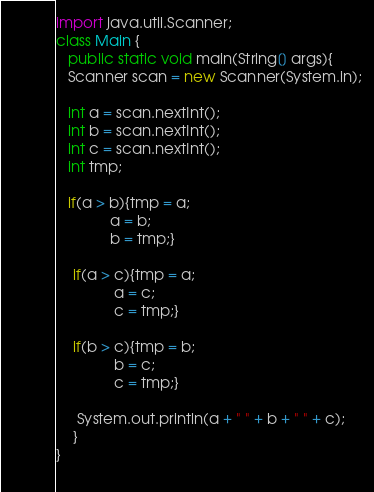<code> <loc_0><loc_0><loc_500><loc_500><_Java_>import java.util.Scanner;
class Main {
   public static void main(String[] args){
   Scanner scan = new Scanner(System.in);
 
   int a = scan.nextInt();
   int b = scan.nextInt();
   int c = scan.nextInt();
   int tmp;
 
   if(a > b){tmp = a;
             a = b;
             b = tmp;}
 
    if(a > c){tmp = a;
              a = c;
              c = tmp;}
  
    if(b > c){tmp = b;
              b = c;
              c = tmp;}
 
     System.out.println(a + " " + b + " " + c);
    }
}
 </code> 